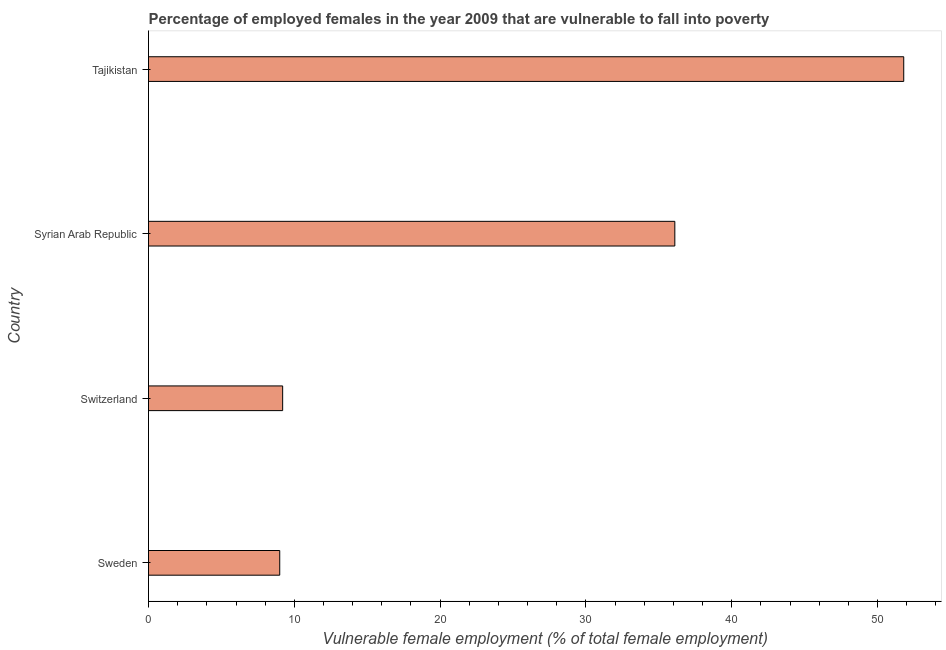Does the graph contain any zero values?
Ensure brevity in your answer.  No. What is the title of the graph?
Offer a very short reply. Percentage of employed females in the year 2009 that are vulnerable to fall into poverty. What is the label or title of the X-axis?
Provide a short and direct response. Vulnerable female employment (% of total female employment). What is the percentage of employed females who are vulnerable to fall into poverty in Switzerland?
Give a very brief answer. 9.2. Across all countries, what is the maximum percentage of employed females who are vulnerable to fall into poverty?
Your response must be concise. 51.8. Across all countries, what is the minimum percentage of employed females who are vulnerable to fall into poverty?
Keep it short and to the point. 9. In which country was the percentage of employed females who are vulnerable to fall into poverty maximum?
Keep it short and to the point. Tajikistan. In which country was the percentage of employed females who are vulnerable to fall into poverty minimum?
Provide a short and direct response. Sweden. What is the sum of the percentage of employed females who are vulnerable to fall into poverty?
Provide a succinct answer. 106.1. What is the difference between the percentage of employed females who are vulnerable to fall into poverty in Sweden and Tajikistan?
Offer a very short reply. -42.8. What is the average percentage of employed females who are vulnerable to fall into poverty per country?
Provide a short and direct response. 26.52. What is the median percentage of employed females who are vulnerable to fall into poverty?
Provide a succinct answer. 22.65. In how many countries, is the percentage of employed females who are vulnerable to fall into poverty greater than 2 %?
Provide a short and direct response. 4. What is the ratio of the percentage of employed females who are vulnerable to fall into poverty in Sweden to that in Syrian Arab Republic?
Provide a short and direct response. 0.25. Is the difference between the percentage of employed females who are vulnerable to fall into poverty in Sweden and Switzerland greater than the difference between any two countries?
Offer a very short reply. No. Is the sum of the percentage of employed females who are vulnerable to fall into poverty in Syrian Arab Republic and Tajikistan greater than the maximum percentage of employed females who are vulnerable to fall into poverty across all countries?
Provide a short and direct response. Yes. What is the difference between the highest and the lowest percentage of employed females who are vulnerable to fall into poverty?
Ensure brevity in your answer.  42.8. How many bars are there?
Offer a terse response. 4. How many countries are there in the graph?
Offer a terse response. 4. What is the Vulnerable female employment (% of total female employment) of Switzerland?
Your answer should be very brief. 9.2. What is the Vulnerable female employment (% of total female employment) of Syrian Arab Republic?
Give a very brief answer. 36.1. What is the Vulnerable female employment (% of total female employment) in Tajikistan?
Keep it short and to the point. 51.8. What is the difference between the Vulnerable female employment (% of total female employment) in Sweden and Switzerland?
Provide a short and direct response. -0.2. What is the difference between the Vulnerable female employment (% of total female employment) in Sweden and Syrian Arab Republic?
Keep it short and to the point. -27.1. What is the difference between the Vulnerable female employment (% of total female employment) in Sweden and Tajikistan?
Offer a terse response. -42.8. What is the difference between the Vulnerable female employment (% of total female employment) in Switzerland and Syrian Arab Republic?
Your response must be concise. -26.9. What is the difference between the Vulnerable female employment (% of total female employment) in Switzerland and Tajikistan?
Give a very brief answer. -42.6. What is the difference between the Vulnerable female employment (% of total female employment) in Syrian Arab Republic and Tajikistan?
Provide a succinct answer. -15.7. What is the ratio of the Vulnerable female employment (% of total female employment) in Sweden to that in Syrian Arab Republic?
Provide a short and direct response. 0.25. What is the ratio of the Vulnerable female employment (% of total female employment) in Sweden to that in Tajikistan?
Offer a terse response. 0.17. What is the ratio of the Vulnerable female employment (% of total female employment) in Switzerland to that in Syrian Arab Republic?
Provide a succinct answer. 0.26. What is the ratio of the Vulnerable female employment (% of total female employment) in Switzerland to that in Tajikistan?
Offer a very short reply. 0.18. What is the ratio of the Vulnerable female employment (% of total female employment) in Syrian Arab Republic to that in Tajikistan?
Give a very brief answer. 0.7. 